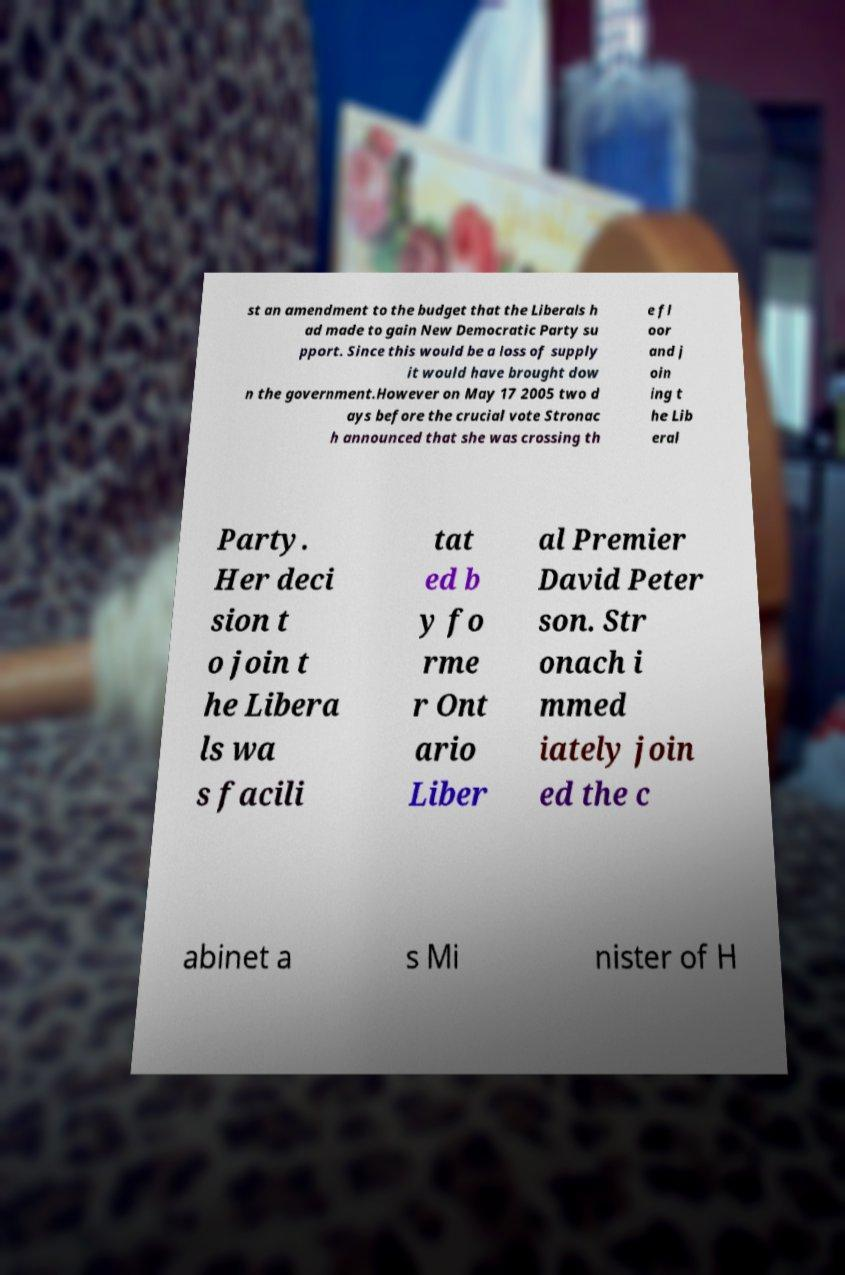There's text embedded in this image that I need extracted. Can you transcribe it verbatim? st an amendment to the budget that the Liberals h ad made to gain New Democratic Party su pport. Since this would be a loss of supply it would have brought dow n the government.However on May 17 2005 two d ays before the crucial vote Stronac h announced that she was crossing th e fl oor and j oin ing t he Lib eral Party. Her deci sion t o join t he Libera ls wa s facili tat ed b y fo rme r Ont ario Liber al Premier David Peter son. Str onach i mmed iately join ed the c abinet a s Mi nister of H 